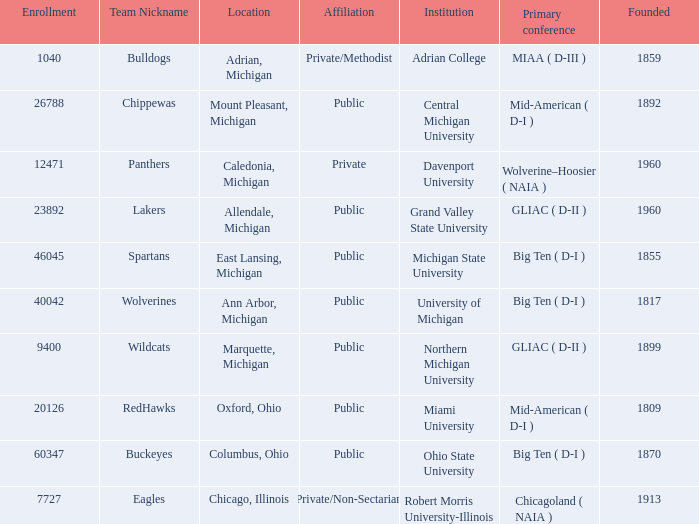What is the enrollment for the Redhawks? 1.0. 